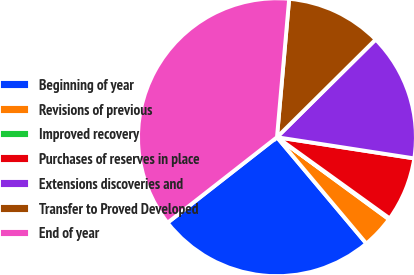<chart> <loc_0><loc_0><loc_500><loc_500><pie_chart><fcel>Beginning of year<fcel>Revisions of previous<fcel>Improved recovery<fcel>Purchases of reserves in place<fcel>Extensions discoveries and<fcel>Transfer to Proved Developed<fcel>End of year<nl><fcel>25.57%<fcel>3.81%<fcel>0.13%<fcel>7.5%<fcel>14.86%<fcel>11.18%<fcel>36.96%<nl></chart> 